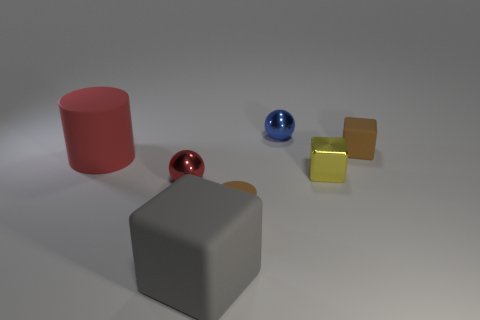How many other blue metallic things have the same size as the blue metallic thing?
Offer a very short reply. 0. There is a metal ball that is in front of the tiny sphere that is behind the large cylinder; how big is it?
Offer a terse response. Small. Is the shape of the matte thing that is behind the large red matte cylinder the same as the brown matte thing in front of the metal cube?
Offer a terse response. No. There is a matte object that is left of the small brown matte cylinder and behind the large cube; what color is it?
Your answer should be very brief. Red. Are there any metallic objects of the same color as the big rubber cube?
Offer a very short reply. No. There is a big object left of the gray rubber block; what is its color?
Provide a succinct answer. Red. Are there any matte cylinders to the right of the metallic thing to the left of the large gray rubber object?
Offer a very short reply. Yes. Is the color of the small metallic cube the same as the large block left of the tiny brown matte cube?
Provide a succinct answer. No. Are there any things made of the same material as the yellow block?
Your response must be concise. Yes. What number of small blue cylinders are there?
Provide a succinct answer. 0. 